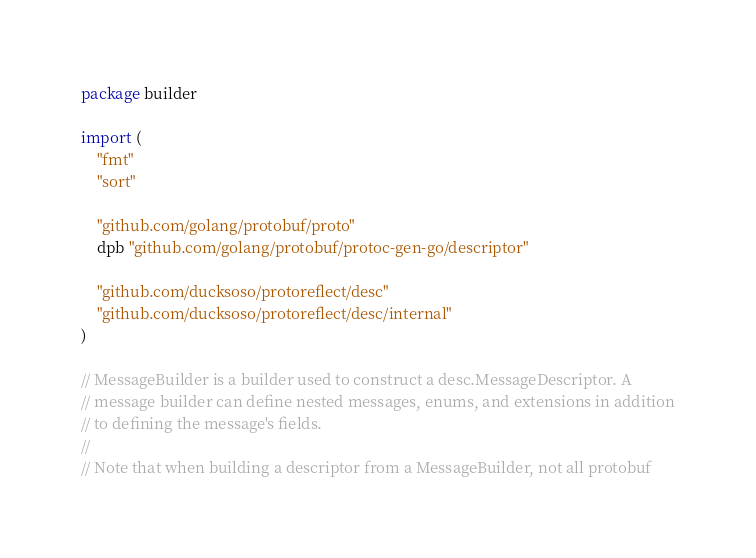<code> <loc_0><loc_0><loc_500><loc_500><_Go_>package builder

import (
	"fmt"
	"sort"

	"github.com/golang/protobuf/proto"
	dpb "github.com/golang/protobuf/protoc-gen-go/descriptor"

	"github.com/ducksoso/protoreflect/desc"
	"github.com/ducksoso/protoreflect/desc/internal"
)

// MessageBuilder is a builder used to construct a desc.MessageDescriptor. A
// message builder can define nested messages, enums, and extensions in addition
// to defining the message's fields.
//
// Note that when building a descriptor from a MessageBuilder, not all protobuf</code> 